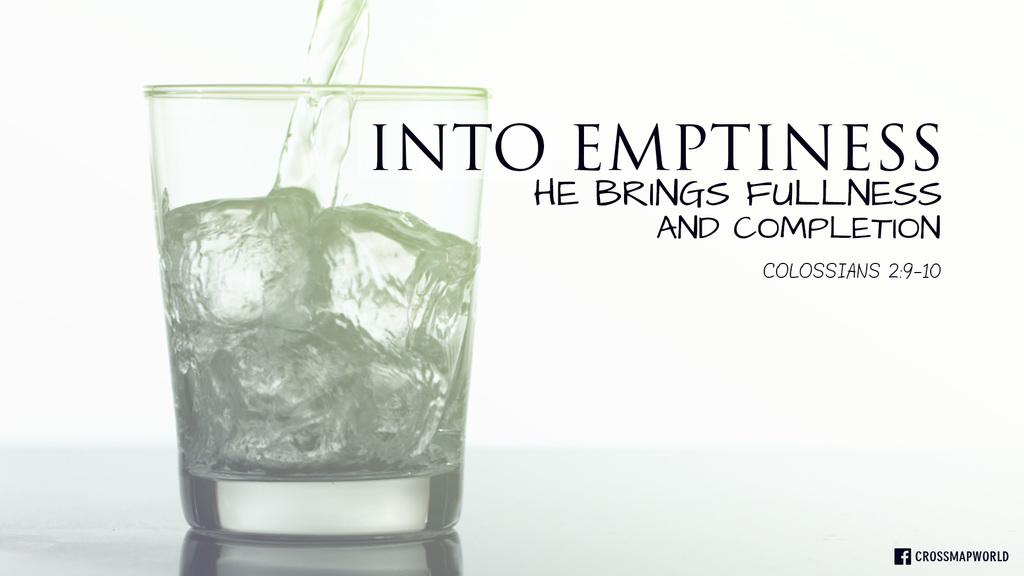<image>
Describe the image concisely. A glass with ice in it and water pouring into it that says Into Emptiness He Brings Fullness and Completion on it. 